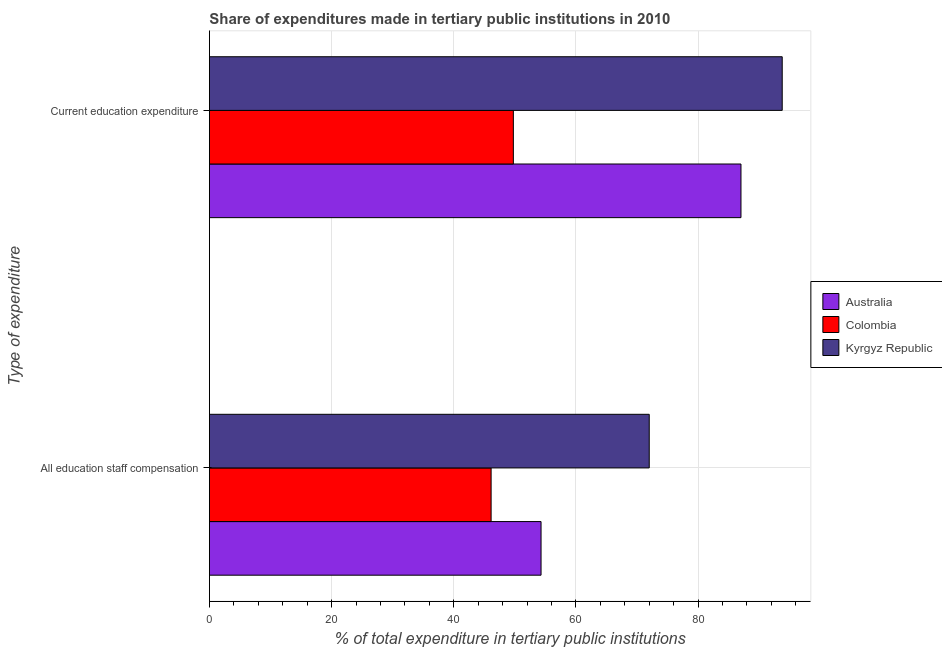How many groups of bars are there?
Your answer should be compact. 2. Are the number of bars on each tick of the Y-axis equal?
Your response must be concise. Yes. How many bars are there on the 2nd tick from the top?
Give a very brief answer. 3. What is the label of the 1st group of bars from the top?
Your answer should be compact. Current education expenditure. What is the expenditure in education in Australia?
Give a very brief answer. 87.02. Across all countries, what is the maximum expenditure in staff compensation?
Your response must be concise. 72.01. Across all countries, what is the minimum expenditure in education?
Offer a terse response. 49.76. In which country was the expenditure in education maximum?
Ensure brevity in your answer.  Kyrgyz Republic. In which country was the expenditure in staff compensation minimum?
Your answer should be compact. Colombia. What is the total expenditure in education in the graph?
Give a very brief answer. 230.56. What is the difference between the expenditure in education in Kyrgyz Republic and that in Colombia?
Offer a very short reply. 44.02. What is the difference between the expenditure in staff compensation in Colombia and the expenditure in education in Kyrgyz Republic?
Provide a short and direct response. -47.66. What is the average expenditure in education per country?
Provide a succinct answer. 76.85. What is the difference between the expenditure in staff compensation and expenditure in education in Kyrgyz Republic?
Give a very brief answer. -21.77. What is the ratio of the expenditure in education in Colombia to that in Kyrgyz Republic?
Make the answer very short. 0.53. What does the 1st bar from the top in Current education expenditure represents?
Provide a short and direct response. Kyrgyz Republic. Are all the bars in the graph horizontal?
Provide a succinct answer. Yes. How many countries are there in the graph?
Provide a short and direct response. 3. What is the difference between two consecutive major ticks on the X-axis?
Provide a short and direct response. 20. Are the values on the major ticks of X-axis written in scientific E-notation?
Offer a terse response. No. Does the graph contain any zero values?
Offer a very short reply. No. Does the graph contain grids?
Offer a very short reply. Yes. Where does the legend appear in the graph?
Offer a terse response. Center right. What is the title of the graph?
Make the answer very short. Share of expenditures made in tertiary public institutions in 2010. Does "Kuwait" appear as one of the legend labels in the graph?
Ensure brevity in your answer.  No. What is the label or title of the X-axis?
Offer a very short reply. % of total expenditure in tertiary public institutions. What is the label or title of the Y-axis?
Make the answer very short. Type of expenditure. What is the % of total expenditure in tertiary public institutions in Australia in All education staff compensation?
Ensure brevity in your answer.  54.29. What is the % of total expenditure in tertiary public institutions in Colombia in All education staff compensation?
Offer a very short reply. 46.12. What is the % of total expenditure in tertiary public institutions of Kyrgyz Republic in All education staff compensation?
Offer a terse response. 72.01. What is the % of total expenditure in tertiary public institutions of Australia in Current education expenditure?
Your answer should be compact. 87.02. What is the % of total expenditure in tertiary public institutions in Colombia in Current education expenditure?
Ensure brevity in your answer.  49.76. What is the % of total expenditure in tertiary public institutions of Kyrgyz Republic in Current education expenditure?
Your response must be concise. 93.77. Across all Type of expenditure, what is the maximum % of total expenditure in tertiary public institutions of Australia?
Offer a terse response. 87.02. Across all Type of expenditure, what is the maximum % of total expenditure in tertiary public institutions in Colombia?
Your answer should be compact. 49.76. Across all Type of expenditure, what is the maximum % of total expenditure in tertiary public institutions of Kyrgyz Republic?
Your response must be concise. 93.77. Across all Type of expenditure, what is the minimum % of total expenditure in tertiary public institutions in Australia?
Keep it short and to the point. 54.29. Across all Type of expenditure, what is the minimum % of total expenditure in tertiary public institutions of Colombia?
Provide a short and direct response. 46.12. Across all Type of expenditure, what is the minimum % of total expenditure in tertiary public institutions of Kyrgyz Republic?
Give a very brief answer. 72.01. What is the total % of total expenditure in tertiary public institutions in Australia in the graph?
Provide a short and direct response. 141.32. What is the total % of total expenditure in tertiary public institutions in Colombia in the graph?
Keep it short and to the point. 95.88. What is the total % of total expenditure in tertiary public institutions in Kyrgyz Republic in the graph?
Provide a short and direct response. 165.78. What is the difference between the % of total expenditure in tertiary public institutions of Australia in All education staff compensation and that in Current education expenditure?
Provide a short and direct response. -32.73. What is the difference between the % of total expenditure in tertiary public institutions of Colombia in All education staff compensation and that in Current education expenditure?
Provide a short and direct response. -3.64. What is the difference between the % of total expenditure in tertiary public institutions of Kyrgyz Republic in All education staff compensation and that in Current education expenditure?
Offer a terse response. -21.77. What is the difference between the % of total expenditure in tertiary public institutions in Australia in All education staff compensation and the % of total expenditure in tertiary public institutions in Colombia in Current education expenditure?
Your answer should be compact. 4.53. What is the difference between the % of total expenditure in tertiary public institutions of Australia in All education staff compensation and the % of total expenditure in tertiary public institutions of Kyrgyz Republic in Current education expenditure?
Your answer should be compact. -39.48. What is the difference between the % of total expenditure in tertiary public institutions of Colombia in All education staff compensation and the % of total expenditure in tertiary public institutions of Kyrgyz Republic in Current education expenditure?
Provide a succinct answer. -47.66. What is the average % of total expenditure in tertiary public institutions of Australia per Type of expenditure?
Your response must be concise. 70.66. What is the average % of total expenditure in tertiary public institutions of Colombia per Type of expenditure?
Provide a short and direct response. 47.94. What is the average % of total expenditure in tertiary public institutions in Kyrgyz Republic per Type of expenditure?
Your answer should be compact. 82.89. What is the difference between the % of total expenditure in tertiary public institutions of Australia and % of total expenditure in tertiary public institutions of Colombia in All education staff compensation?
Give a very brief answer. 8.18. What is the difference between the % of total expenditure in tertiary public institutions of Australia and % of total expenditure in tertiary public institutions of Kyrgyz Republic in All education staff compensation?
Provide a short and direct response. -17.71. What is the difference between the % of total expenditure in tertiary public institutions of Colombia and % of total expenditure in tertiary public institutions of Kyrgyz Republic in All education staff compensation?
Ensure brevity in your answer.  -25.89. What is the difference between the % of total expenditure in tertiary public institutions of Australia and % of total expenditure in tertiary public institutions of Colombia in Current education expenditure?
Provide a succinct answer. 37.26. What is the difference between the % of total expenditure in tertiary public institutions of Australia and % of total expenditure in tertiary public institutions of Kyrgyz Republic in Current education expenditure?
Give a very brief answer. -6.75. What is the difference between the % of total expenditure in tertiary public institutions of Colombia and % of total expenditure in tertiary public institutions of Kyrgyz Republic in Current education expenditure?
Provide a succinct answer. -44.02. What is the ratio of the % of total expenditure in tertiary public institutions in Australia in All education staff compensation to that in Current education expenditure?
Ensure brevity in your answer.  0.62. What is the ratio of the % of total expenditure in tertiary public institutions of Colombia in All education staff compensation to that in Current education expenditure?
Ensure brevity in your answer.  0.93. What is the ratio of the % of total expenditure in tertiary public institutions of Kyrgyz Republic in All education staff compensation to that in Current education expenditure?
Offer a very short reply. 0.77. What is the difference between the highest and the second highest % of total expenditure in tertiary public institutions of Australia?
Offer a terse response. 32.73. What is the difference between the highest and the second highest % of total expenditure in tertiary public institutions of Colombia?
Give a very brief answer. 3.64. What is the difference between the highest and the second highest % of total expenditure in tertiary public institutions of Kyrgyz Republic?
Make the answer very short. 21.77. What is the difference between the highest and the lowest % of total expenditure in tertiary public institutions of Australia?
Your answer should be very brief. 32.73. What is the difference between the highest and the lowest % of total expenditure in tertiary public institutions of Colombia?
Offer a very short reply. 3.64. What is the difference between the highest and the lowest % of total expenditure in tertiary public institutions in Kyrgyz Republic?
Your answer should be compact. 21.77. 